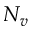<formula> <loc_0><loc_0><loc_500><loc_500>N _ { v }</formula> 